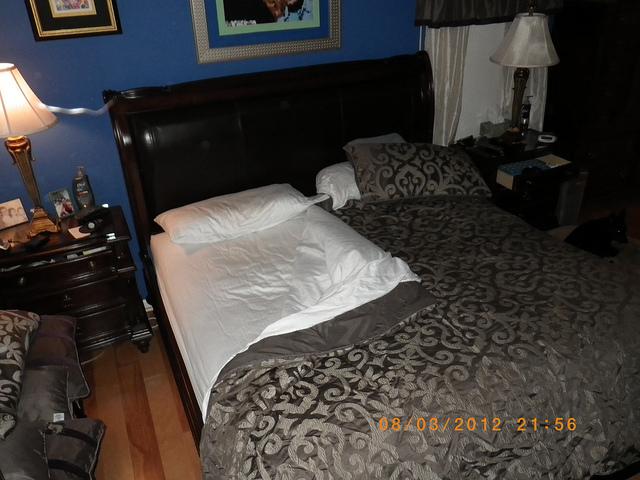What pattern is on the bed sheets?
Write a very short answer. Paisley. When was the photo taken?
Concise answer only. Night. What color is the wall?
Write a very short answer. Blue. Is this a designer bedroom?
Be succinct. No. What date was this picture taken?
Be succinct. 08/03/2012. What side of the bed is opened?
Write a very short answer. Left. 